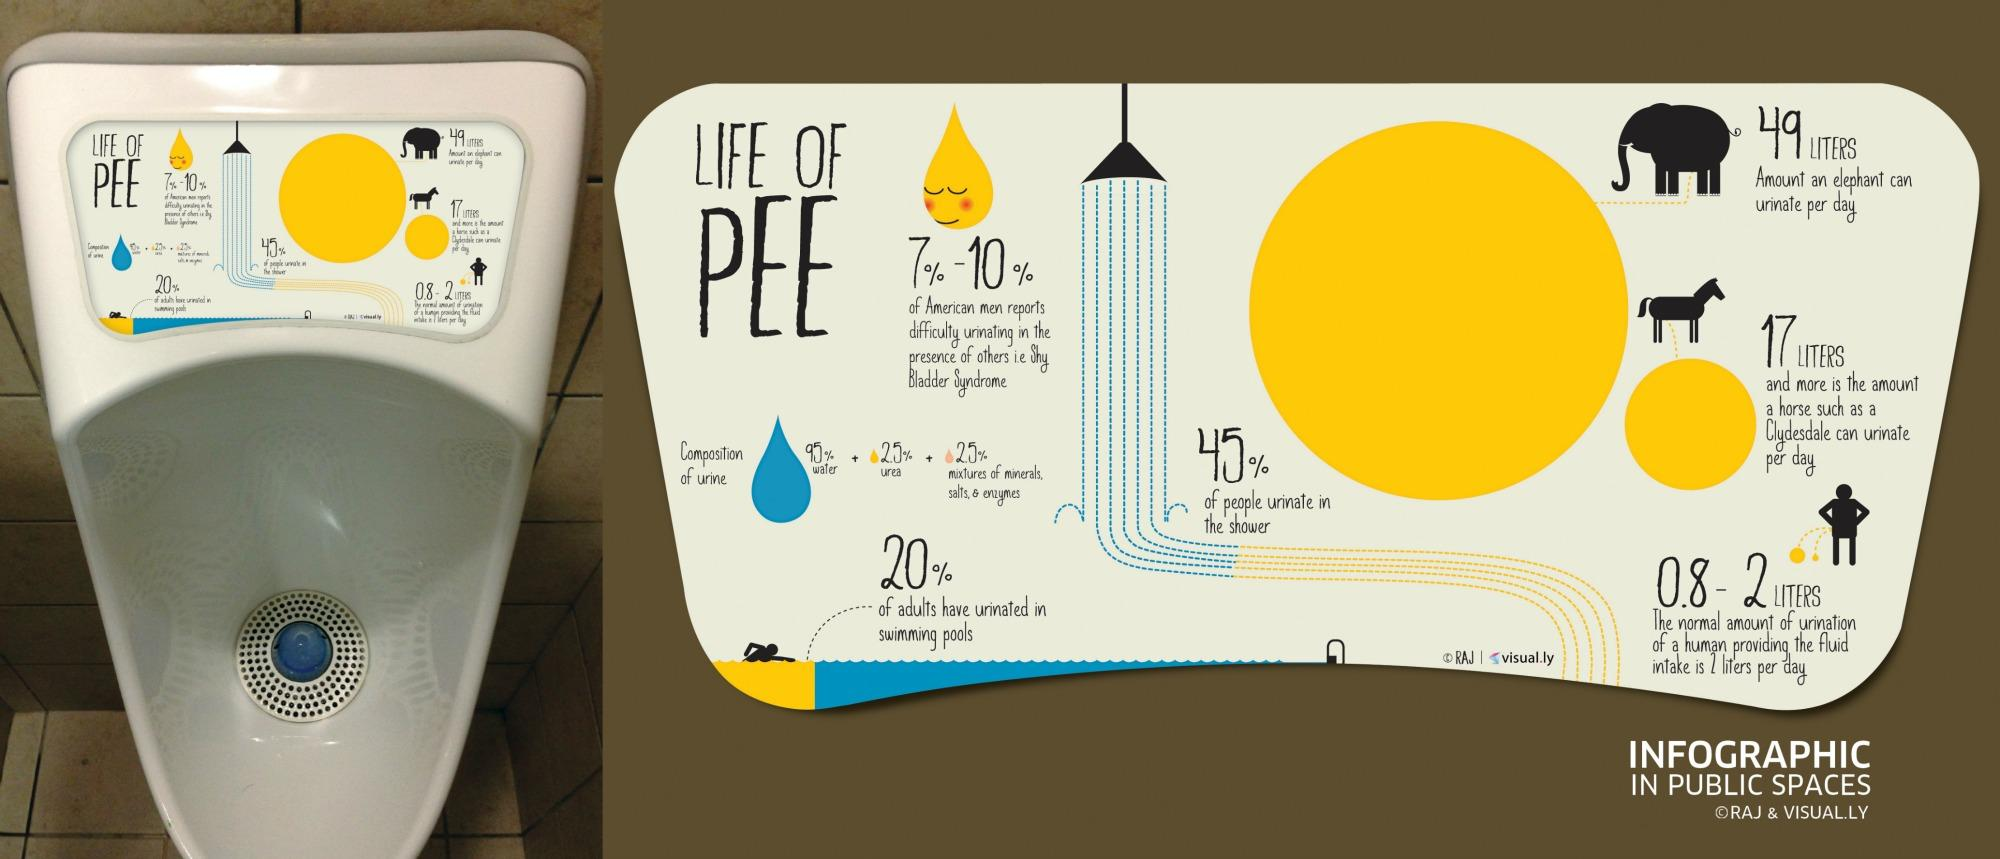Indicate a few pertinent items in this graphic. The infographic depicts that elephants are the animals that urinate the most during a day. Approximately 55% of people do not urinate in the shower. 